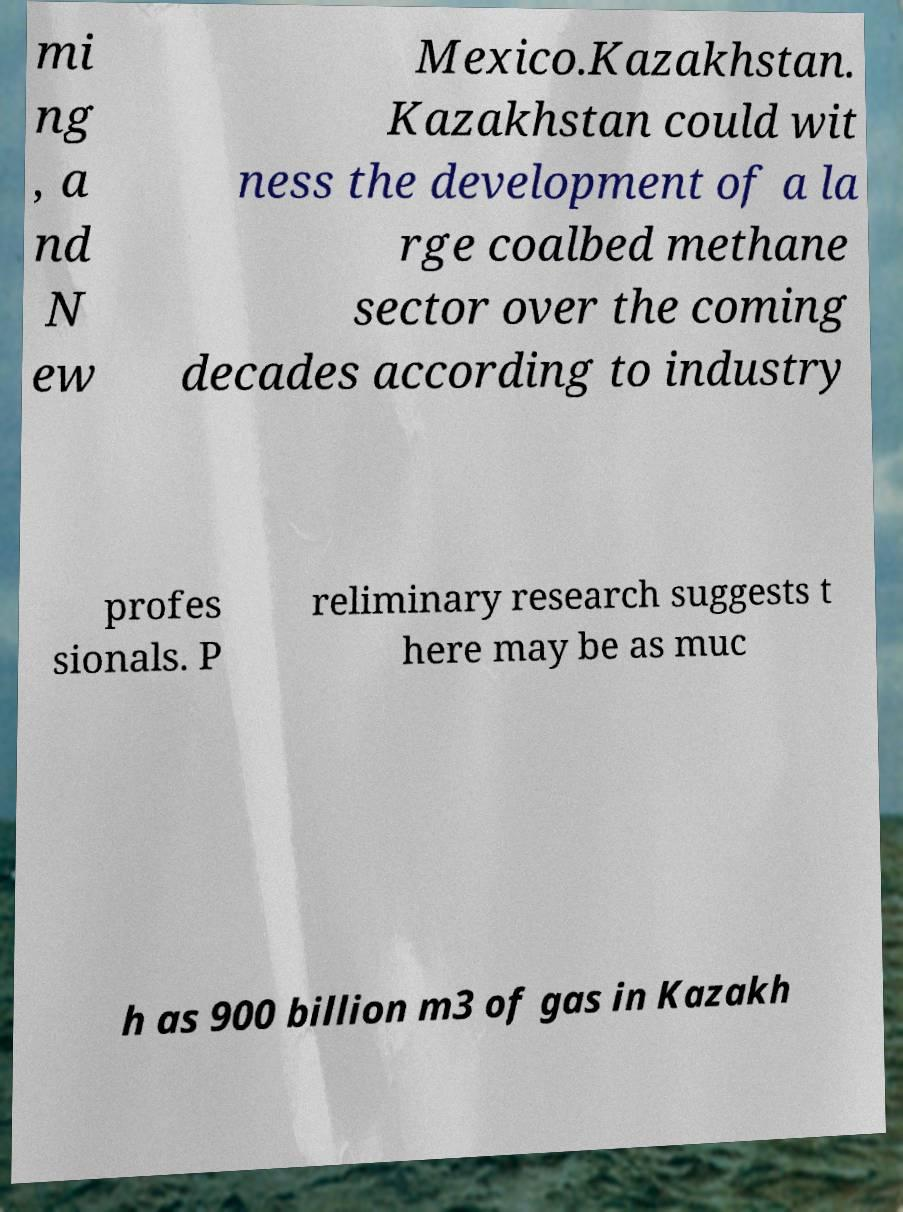Please read and relay the text visible in this image. What does it say? mi ng , a nd N ew Mexico.Kazakhstan. Kazakhstan could wit ness the development of a la rge coalbed methane sector over the coming decades according to industry profes sionals. P reliminary research suggests t here may be as muc h as 900 billion m3 of gas in Kazakh 